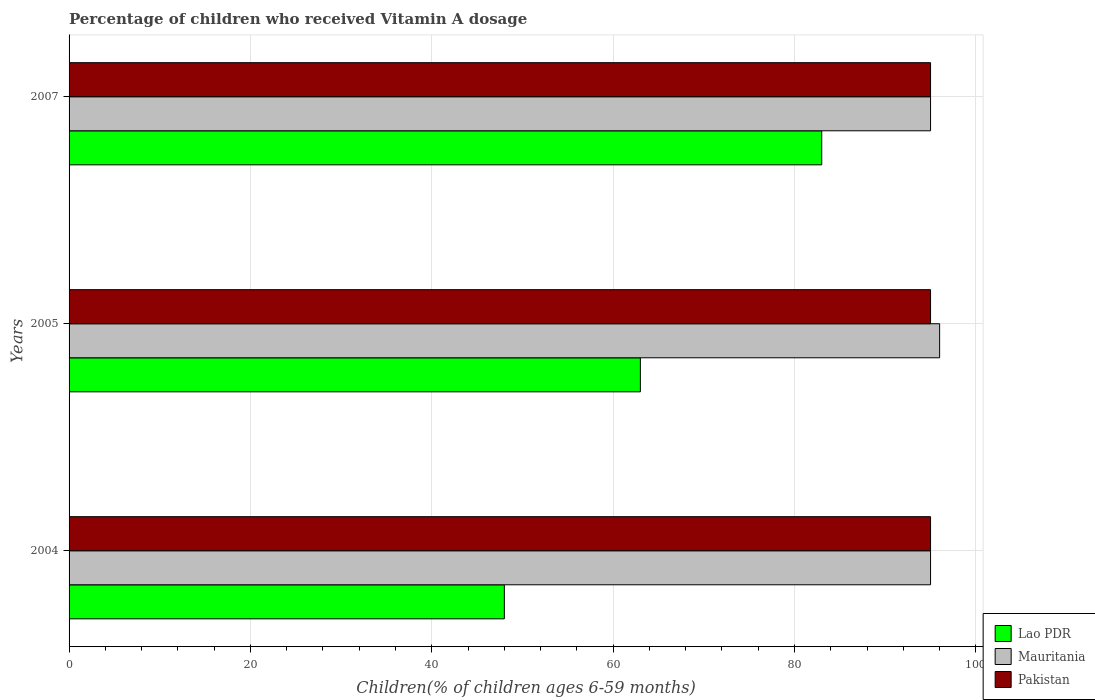How many groups of bars are there?
Ensure brevity in your answer.  3. Are the number of bars per tick equal to the number of legend labels?
Provide a short and direct response. Yes. Are the number of bars on each tick of the Y-axis equal?
Provide a succinct answer. Yes. What is the label of the 3rd group of bars from the top?
Make the answer very short. 2004. What is the percentage of children who received Vitamin A dosage in Lao PDR in 2004?
Provide a succinct answer. 48. Across all years, what is the maximum percentage of children who received Vitamin A dosage in Lao PDR?
Give a very brief answer. 83. Across all years, what is the minimum percentage of children who received Vitamin A dosage in Pakistan?
Give a very brief answer. 95. In which year was the percentage of children who received Vitamin A dosage in Pakistan maximum?
Give a very brief answer. 2004. What is the total percentage of children who received Vitamin A dosage in Pakistan in the graph?
Give a very brief answer. 285. What is the ratio of the percentage of children who received Vitamin A dosage in Pakistan in 2004 to that in 2007?
Your answer should be compact. 1. What is the difference between the highest and the lowest percentage of children who received Vitamin A dosage in Pakistan?
Provide a succinct answer. 0. In how many years, is the percentage of children who received Vitamin A dosage in Mauritania greater than the average percentage of children who received Vitamin A dosage in Mauritania taken over all years?
Give a very brief answer. 1. Is the sum of the percentage of children who received Vitamin A dosage in Pakistan in 2004 and 2007 greater than the maximum percentage of children who received Vitamin A dosage in Mauritania across all years?
Your response must be concise. Yes. What does the 3rd bar from the top in 2005 represents?
Keep it short and to the point. Lao PDR. What does the 1st bar from the bottom in 2004 represents?
Provide a short and direct response. Lao PDR. How many years are there in the graph?
Your answer should be very brief. 3. Does the graph contain any zero values?
Your answer should be very brief. No. Where does the legend appear in the graph?
Offer a very short reply. Bottom right. How are the legend labels stacked?
Give a very brief answer. Vertical. What is the title of the graph?
Ensure brevity in your answer.  Percentage of children who received Vitamin A dosage. What is the label or title of the X-axis?
Give a very brief answer. Children(% of children ages 6-59 months). What is the label or title of the Y-axis?
Provide a short and direct response. Years. What is the Children(% of children ages 6-59 months) of Mauritania in 2004?
Make the answer very short. 95. What is the Children(% of children ages 6-59 months) of Pakistan in 2004?
Offer a terse response. 95. What is the Children(% of children ages 6-59 months) of Lao PDR in 2005?
Your answer should be compact. 63. What is the Children(% of children ages 6-59 months) of Mauritania in 2005?
Keep it short and to the point. 96. What is the Children(% of children ages 6-59 months) in Lao PDR in 2007?
Offer a very short reply. 83. What is the Children(% of children ages 6-59 months) in Pakistan in 2007?
Keep it short and to the point. 95. Across all years, what is the maximum Children(% of children ages 6-59 months) of Mauritania?
Your response must be concise. 96. Across all years, what is the maximum Children(% of children ages 6-59 months) of Pakistan?
Make the answer very short. 95. Across all years, what is the minimum Children(% of children ages 6-59 months) of Lao PDR?
Provide a succinct answer. 48. Across all years, what is the minimum Children(% of children ages 6-59 months) of Mauritania?
Ensure brevity in your answer.  95. What is the total Children(% of children ages 6-59 months) of Lao PDR in the graph?
Offer a terse response. 194. What is the total Children(% of children ages 6-59 months) of Mauritania in the graph?
Your response must be concise. 286. What is the total Children(% of children ages 6-59 months) in Pakistan in the graph?
Provide a short and direct response. 285. What is the difference between the Children(% of children ages 6-59 months) in Pakistan in 2004 and that in 2005?
Offer a terse response. 0. What is the difference between the Children(% of children ages 6-59 months) of Lao PDR in 2004 and that in 2007?
Provide a short and direct response. -35. What is the difference between the Children(% of children ages 6-59 months) in Mauritania in 2004 and that in 2007?
Ensure brevity in your answer.  0. What is the difference between the Children(% of children ages 6-59 months) of Lao PDR in 2005 and that in 2007?
Make the answer very short. -20. What is the difference between the Children(% of children ages 6-59 months) of Pakistan in 2005 and that in 2007?
Offer a terse response. 0. What is the difference between the Children(% of children ages 6-59 months) of Lao PDR in 2004 and the Children(% of children ages 6-59 months) of Mauritania in 2005?
Make the answer very short. -48. What is the difference between the Children(% of children ages 6-59 months) of Lao PDR in 2004 and the Children(% of children ages 6-59 months) of Pakistan in 2005?
Your answer should be compact. -47. What is the difference between the Children(% of children ages 6-59 months) of Mauritania in 2004 and the Children(% of children ages 6-59 months) of Pakistan in 2005?
Provide a succinct answer. 0. What is the difference between the Children(% of children ages 6-59 months) of Lao PDR in 2004 and the Children(% of children ages 6-59 months) of Mauritania in 2007?
Keep it short and to the point. -47. What is the difference between the Children(% of children ages 6-59 months) in Lao PDR in 2004 and the Children(% of children ages 6-59 months) in Pakistan in 2007?
Make the answer very short. -47. What is the difference between the Children(% of children ages 6-59 months) of Mauritania in 2004 and the Children(% of children ages 6-59 months) of Pakistan in 2007?
Provide a succinct answer. 0. What is the difference between the Children(% of children ages 6-59 months) of Lao PDR in 2005 and the Children(% of children ages 6-59 months) of Mauritania in 2007?
Keep it short and to the point. -32. What is the difference between the Children(% of children ages 6-59 months) of Lao PDR in 2005 and the Children(% of children ages 6-59 months) of Pakistan in 2007?
Your answer should be compact. -32. What is the average Children(% of children ages 6-59 months) in Lao PDR per year?
Your response must be concise. 64.67. What is the average Children(% of children ages 6-59 months) of Mauritania per year?
Offer a terse response. 95.33. What is the average Children(% of children ages 6-59 months) of Pakistan per year?
Keep it short and to the point. 95. In the year 2004, what is the difference between the Children(% of children ages 6-59 months) in Lao PDR and Children(% of children ages 6-59 months) in Mauritania?
Offer a terse response. -47. In the year 2004, what is the difference between the Children(% of children ages 6-59 months) in Lao PDR and Children(% of children ages 6-59 months) in Pakistan?
Offer a terse response. -47. In the year 2005, what is the difference between the Children(% of children ages 6-59 months) of Lao PDR and Children(% of children ages 6-59 months) of Mauritania?
Your response must be concise. -33. In the year 2005, what is the difference between the Children(% of children ages 6-59 months) of Lao PDR and Children(% of children ages 6-59 months) of Pakistan?
Offer a terse response. -32. In the year 2007, what is the difference between the Children(% of children ages 6-59 months) of Lao PDR and Children(% of children ages 6-59 months) of Mauritania?
Make the answer very short. -12. In the year 2007, what is the difference between the Children(% of children ages 6-59 months) of Mauritania and Children(% of children ages 6-59 months) of Pakistan?
Keep it short and to the point. 0. What is the ratio of the Children(% of children ages 6-59 months) of Lao PDR in 2004 to that in 2005?
Offer a very short reply. 0.76. What is the ratio of the Children(% of children ages 6-59 months) of Mauritania in 2004 to that in 2005?
Your response must be concise. 0.99. What is the ratio of the Children(% of children ages 6-59 months) in Pakistan in 2004 to that in 2005?
Your answer should be very brief. 1. What is the ratio of the Children(% of children ages 6-59 months) of Lao PDR in 2004 to that in 2007?
Your response must be concise. 0.58. What is the ratio of the Children(% of children ages 6-59 months) of Pakistan in 2004 to that in 2007?
Provide a short and direct response. 1. What is the ratio of the Children(% of children ages 6-59 months) in Lao PDR in 2005 to that in 2007?
Give a very brief answer. 0.76. What is the ratio of the Children(% of children ages 6-59 months) of Mauritania in 2005 to that in 2007?
Provide a short and direct response. 1.01. What is the difference between the highest and the second highest Children(% of children ages 6-59 months) of Lao PDR?
Offer a very short reply. 20. What is the difference between the highest and the second highest Children(% of children ages 6-59 months) in Mauritania?
Your answer should be compact. 1. What is the difference between the highest and the lowest Children(% of children ages 6-59 months) of Mauritania?
Your answer should be very brief. 1. 